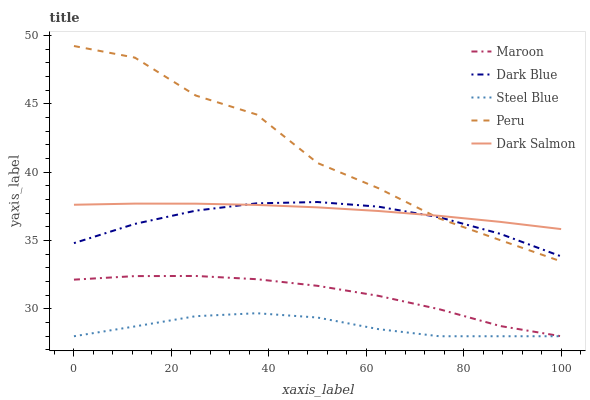Does Steel Blue have the minimum area under the curve?
Answer yes or no. Yes. Does Peru have the maximum area under the curve?
Answer yes or no. Yes. Does Dark Blue have the minimum area under the curve?
Answer yes or no. No. Does Dark Blue have the maximum area under the curve?
Answer yes or no. No. Is Dark Salmon the smoothest?
Answer yes or no. Yes. Is Peru the roughest?
Answer yes or no. Yes. Is Dark Blue the smoothest?
Answer yes or no. No. Is Dark Blue the roughest?
Answer yes or no. No. Does Dark Blue have the lowest value?
Answer yes or no. No. Does Peru have the highest value?
Answer yes or no. Yes. Does Dark Blue have the highest value?
Answer yes or no. No. Is Maroon less than Dark Salmon?
Answer yes or no. Yes. Is Dark Salmon greater than Steel Blue?
Answer yes or no. Yes. Does Dark Salmon intersect Peru?
Answer yes or no. Yes. Is Dark Salmon less than Peru?
Answer yes or no. No. Is Dark Salmon greater than Peru?
Answer yes or no. No. Does Maroon intersect Dark Salmon?
Answer yes or no. No. 